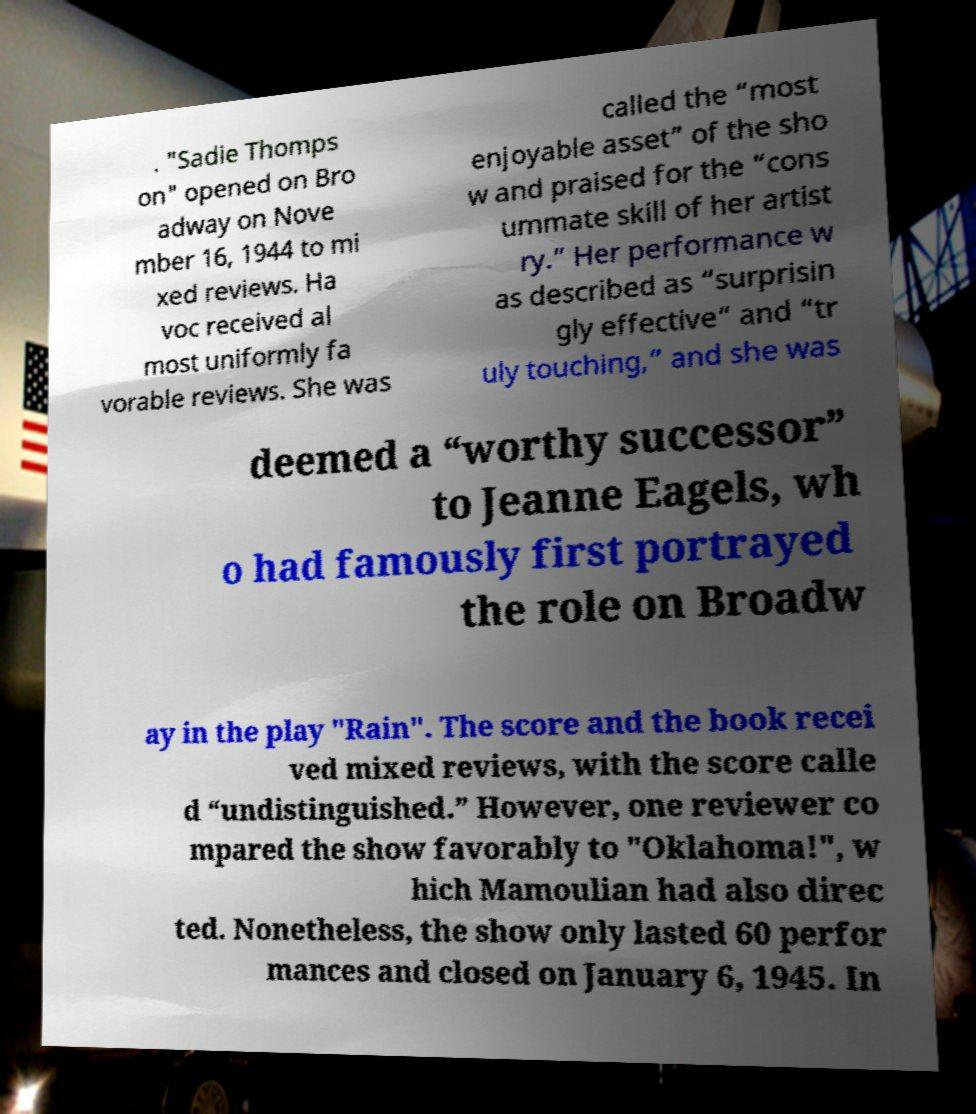For documentation purposes, I need the text within this image transcribed. Could you provide that? . "Sadie Thomps on" opened on Bro adway on Nove mber 16, 1944 to mi xed reviews. Ha voc received al most uniformly fa vorable reviews. She was called the “most enjoyable asset” of the sho w and praised for the “cons ummate skill of her artist ry.” Her performance w as described as “surprisin gly effective“ and “tr uly touching,” and she was deemed a “worthy successor” to Jeanne Eagels, wh o had famously first portrayed the role on Broadw ay in the play "Rain". The score and the book recei ved mixed reviews, with the score calle d “undistinguished.” However, one reviewer co mpared the show favorably to "Oklahoma!", w hich Mamoulian had also direc ted. Nonetheless, the show only lasted 60 perfor mances and closed on January 6, 1945. In 